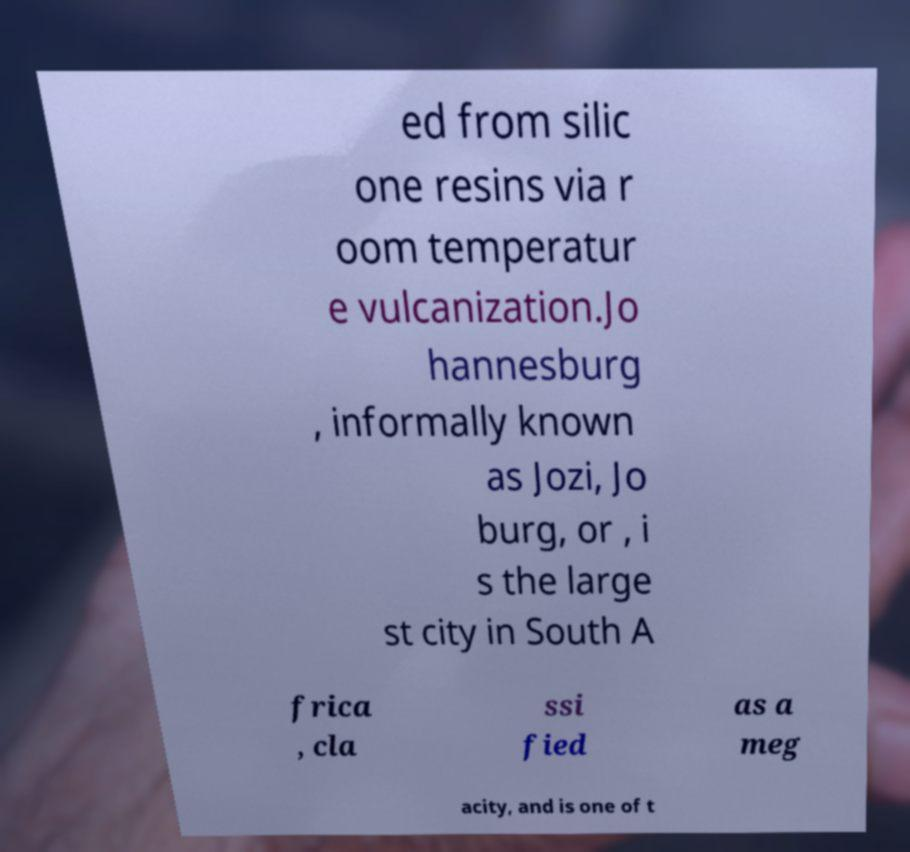Can you accurately transcribe the text from the provided image for me? ed from silic one resins via r oom temperatur e vulcanization.Jo hannesburg , informally known as Jozi, Jo burg, or , i s the large st city in South A frica , cla ssi fied as a meg acity, and is one of t 